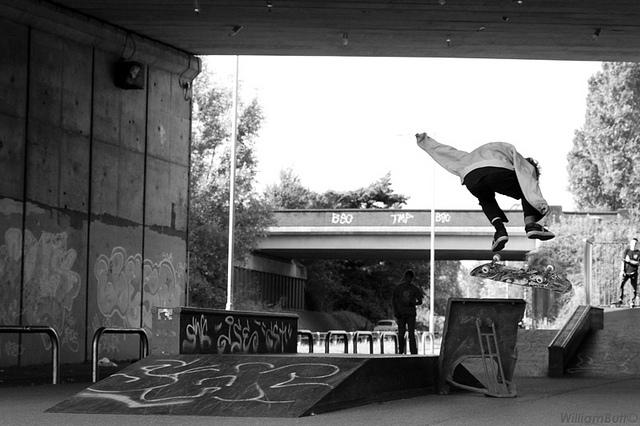How many graffiti pictures are on the overpass wall? three 